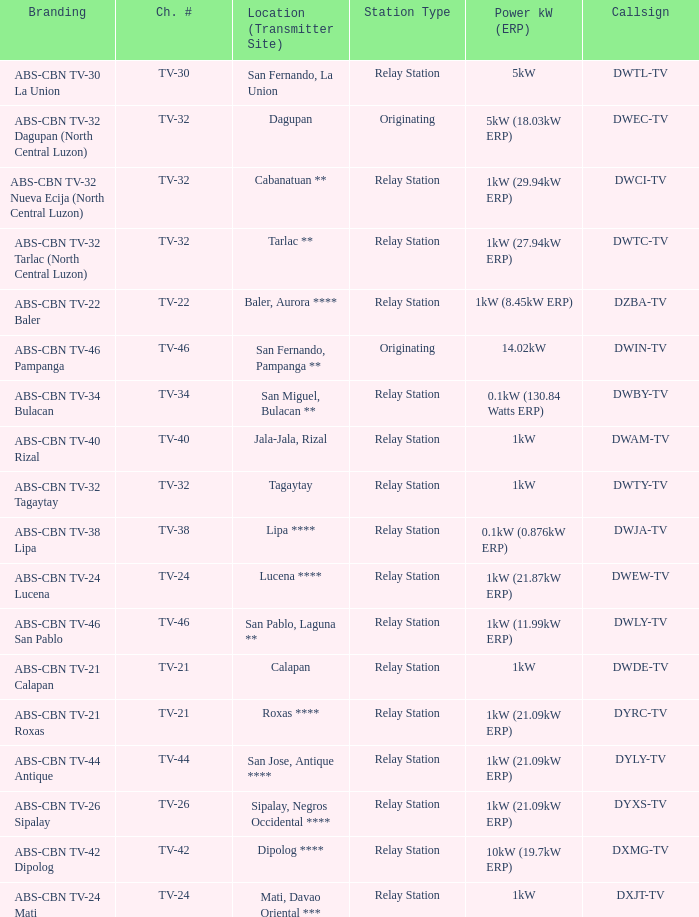What is the branding of the callsign DWCI-TV? ABS-CBN TV-32 Nueva Ecija (North Central Luzon). 